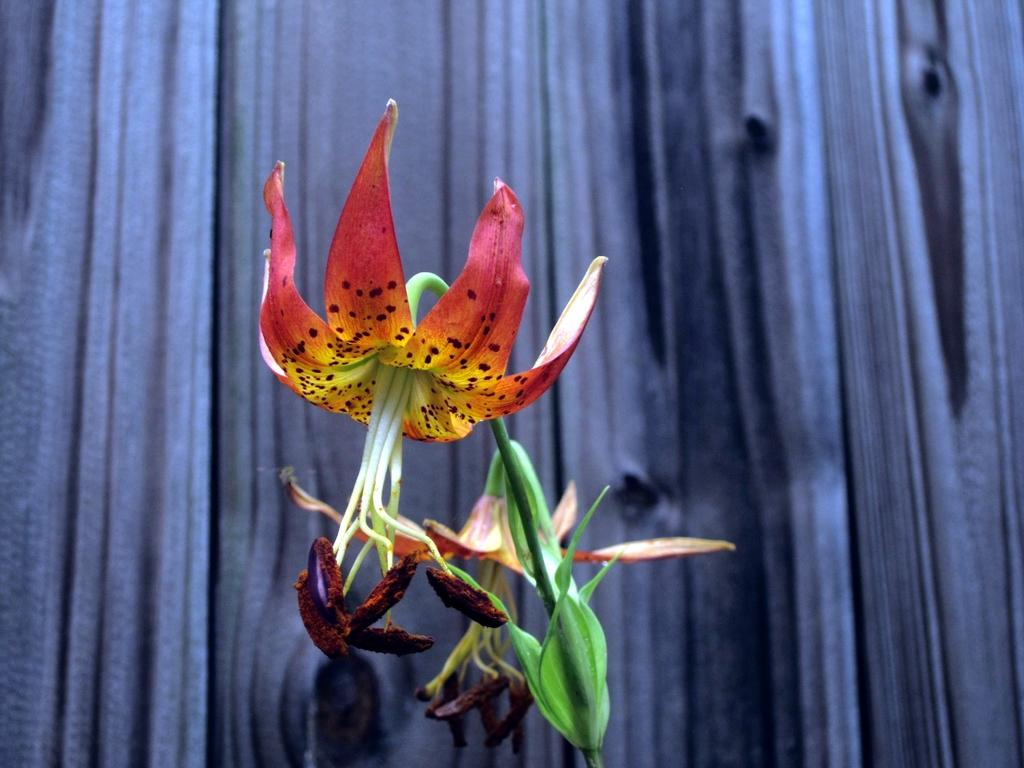What type of plants can be seen in the foreground of the image? There are flowers in the foreground of the image. What is visible in the background of the image? There is a wall in the background of the image. What type of winter clothing is suggested for the flowers in the image? The image does not depict any winter clothing, as it features flowers in the foreground and a wall in the background. --- Facts: 1. There is a person holding a book in the image. 2. The person is sitting on a chair. 3. There is a table next to the chair. 4. The book has a red cover. Absurd Topics: dance, ocean, parrot Conversation: What is the person in the image holding? The person in the image is holding a book. What is the person's position in the image? The person is sitting on a chair. What is located next to the chair? There is a table next to the chair. What color is the book's cover? The book has a red cover. Reasoning: Let's think step by step in order to produce the conversation. We start by identifying the main subject in the image, which is the person holding a book. Then, we describe the person's position, noting that they are sitting on a chair. Next, we mention the presence of a table next to the chair. Finally, we provide information about the book's cover, which is red. Absurd Question/Answer: What type of dance is the person performing with the parrot in the image? There is no dance or parrot present in the image. The image features a person holding a book with a red cover, who is sitting on a chair with a table next to the chair. 